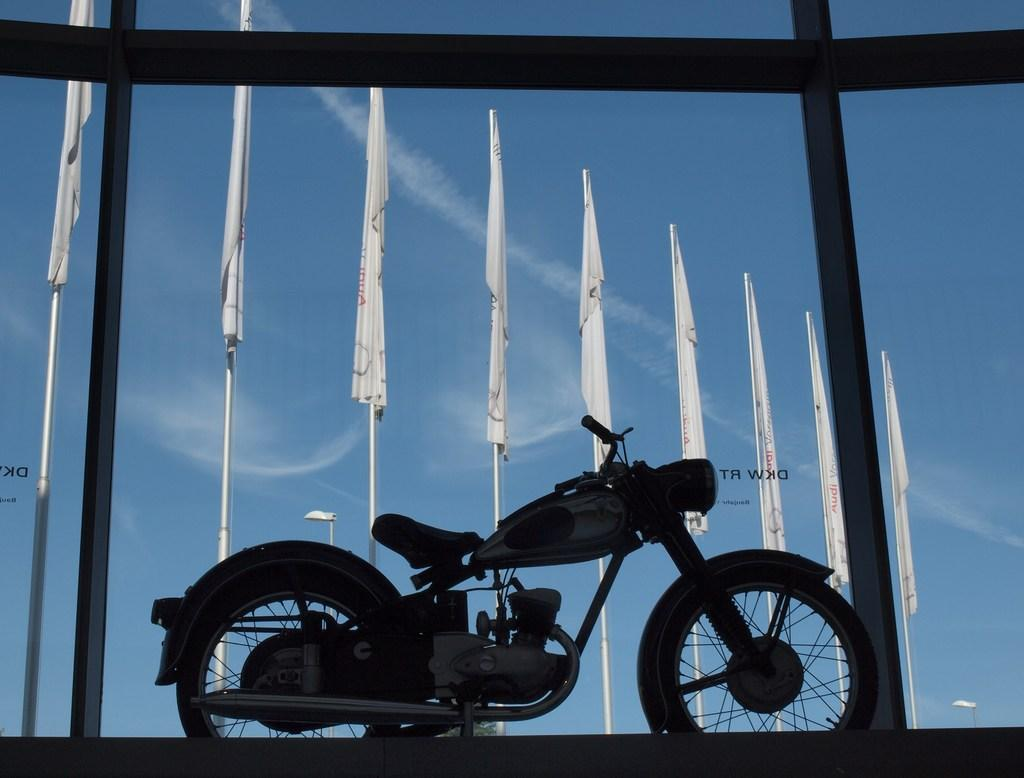What is the main subject of the image? There is a motorbike in the image. What else can be seen in the image besides the motorbike? There is a glass in the image. What is visible through the glass? Flags, poles, and the sky are visible through the glass. What type of star can be seen shining brightly in the image? There is no star visible in the image. How many oranges are placed on the motorbike in the image? There are no oranges present in the image. 